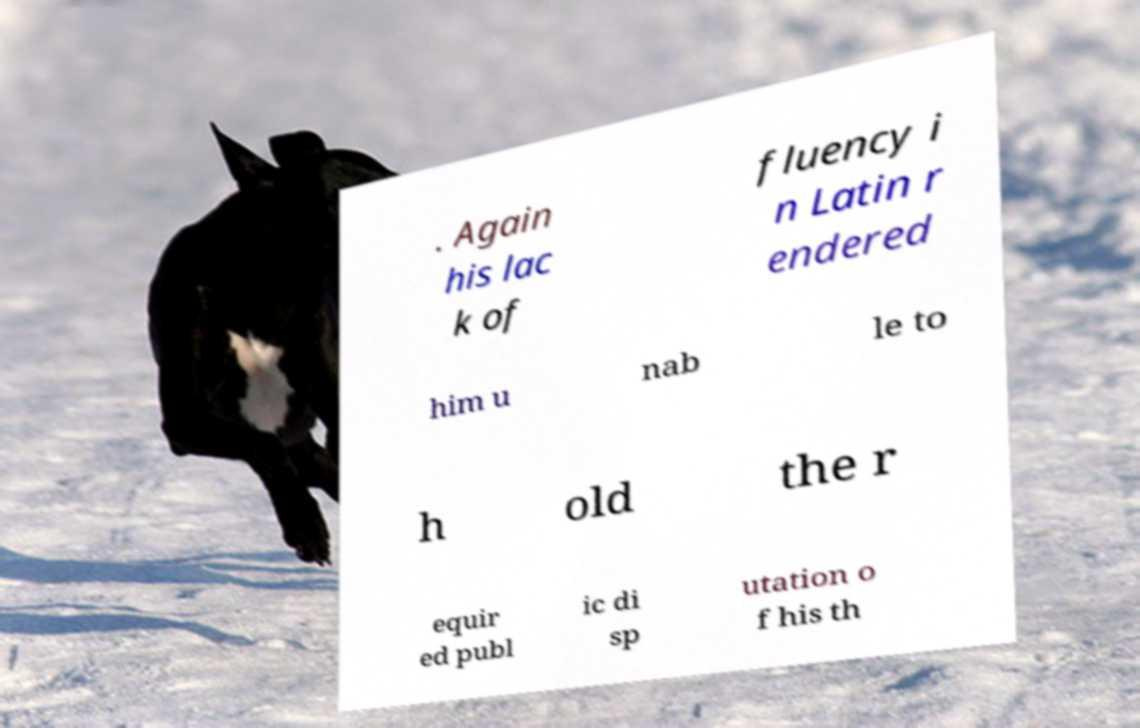Could you assist in decoding the text presented in this image and type it out clearly? . Again his lac k of fluency i n Latin r endered him u nab le to h old the r equir ed publ ic di sp utation o f his th 